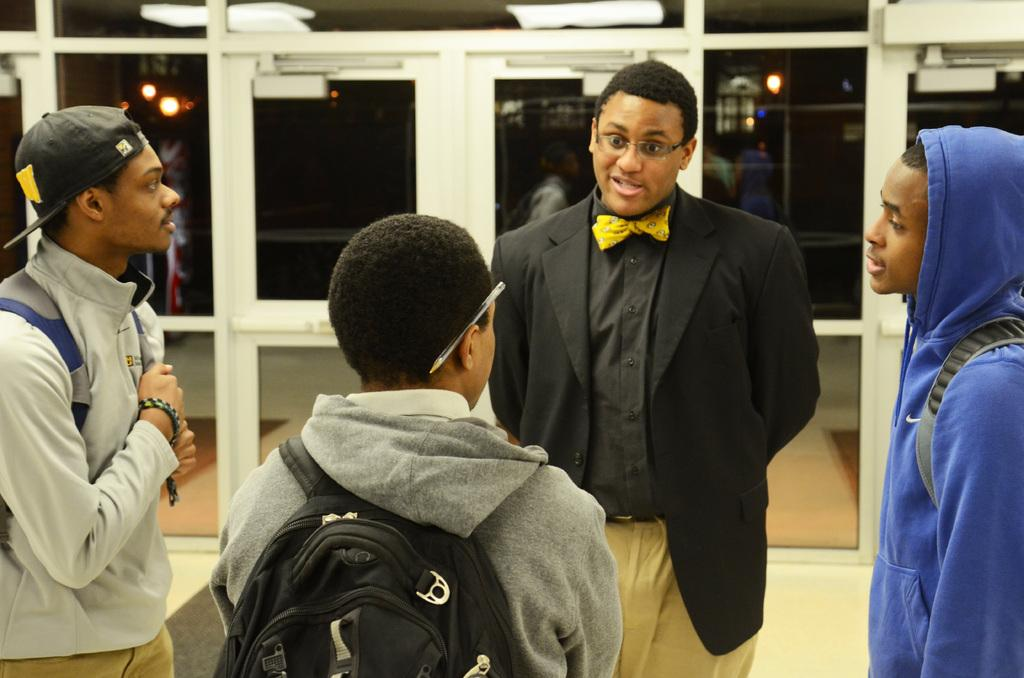What are the people in the image doing? The people in the image are standing. Can you describe any specific detail about one of the people? Yes, one person has a pen on their ear. What type of clothing is the man wearing? The man is wearing a cap. What can be seen through the windows in the image? Windows are visible in the image, but it's not clear what can be seen through them. What type of illumination is present in the image? There are lights visible in the image. What type of mouth can be seen on the border of the image? There is no mouth present on the border of the image. 